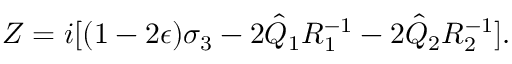<formula> <loc_0><loc_0><loc_500><loc_500>Z = i [ ( 1 - 2 \epsilon ) \sigma _ { 3 } - 2 \hat { Q } _ { 1 } R _ { 1 } ^ { - 1 } - 2 \hat { Q } _ { 2 } R _ { 2 } ^ { - 1 } ] .</formula> 